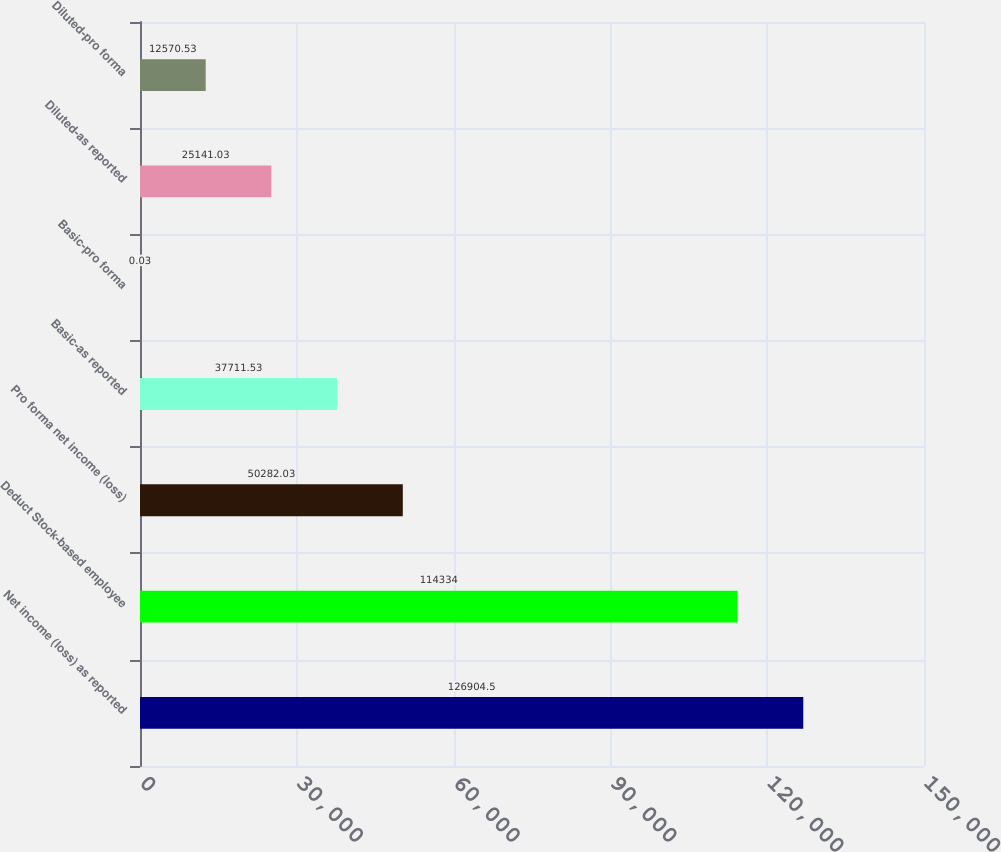Convert chart. <chart><loc_0><loc_0><loc_500><loc_500><bar_chart><fcel>Net income (loss) as reported<fcel>Deduct Stock-based employee<fcel>Pro forma net income (loss)<fcel>Basic-as reported<fcel>Basic-pro forma<fcel>Diluted-as reported<fcel>Diluted-pro forma<nl><fcel>126904<fcel>114334<fcel>50282<fcel>37711.5<fcel>0.03<fcel>25141<fcel>12570.5<nl></chart> 